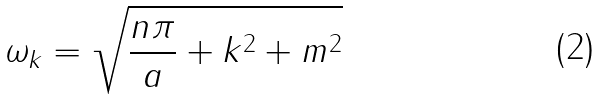Convert formula to latex. <formula><loc_0><loc_0><loc_500><loc_500>\omega _ { k } = \sqrt { \frac { n \pi } { a } + { k } ^ { 2 } + m ^ { 2 } }</formula> 